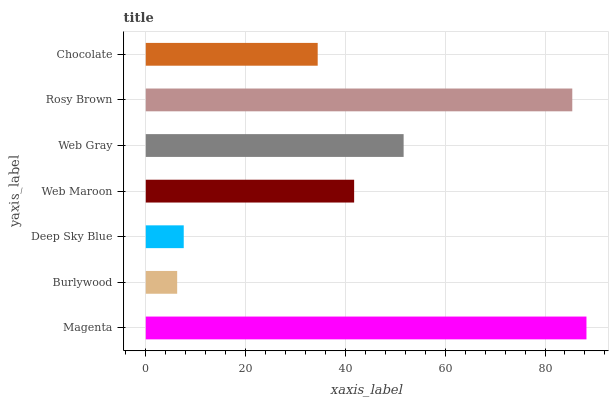Is Burlywood the minimum?
Answer yes or no. Yes. Is Magenta the maximum?
Answer yes or no. Yes. Is Deep Sky Blue the minimum?
Answer yes or no. No. Is Deep Sky Blue the maximum?
Answer yes or no. No. Is Deep Sky Blue greater than Burlywood?
Answer yes or no. Yes. Is Burlywood less than Deep Sky Blue?
Answer yes or no. Yes. Is Burlywood greater than Deep Sky Blue?
Answer yes or no. No. Is Deep Sky Blue less than Burlywood?
Answer yes or no. No. Is Web Maroon the high median?
Answer yes or no. Yes. Is Web Maroon the low median?
Answer yes or no. Yes. Is Chocolate the high median?
Answer yes or no. No. Is Burlywood the low median?
Answer yes or no. No. 